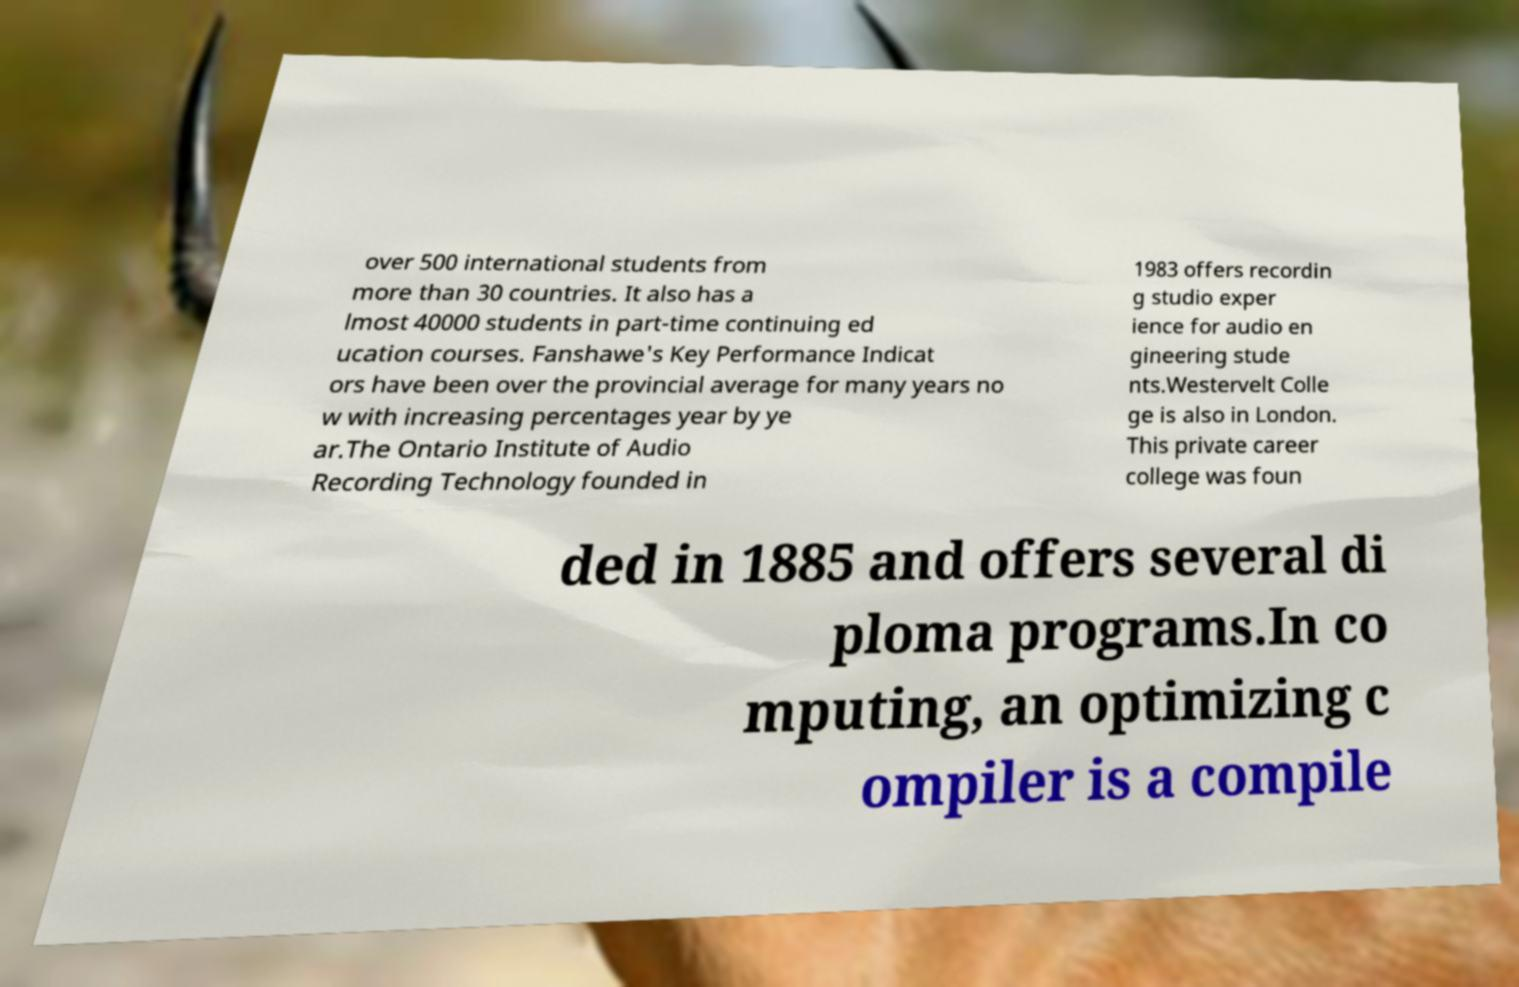I need the written content from this picture converted into text. Can you do that? over 500 international students from more than 30 countries. It also has a lmost 40000 students in part-time continuing ed ucation courses. Fanshawe's Key Performance Indicat ors have been over the provincial average for many years no w with increasing percentages year by ye ar.The Ontario Institute of Audio Recording Technology founded in 1983 offers recordin g studio exper ience for audio en gineering stude nts.Westervelt Colle ge is also in London. This private career college was foun ded in 1885 and offers several di ploma programs.In co mputing, an optimizing c ompiler is a compile 